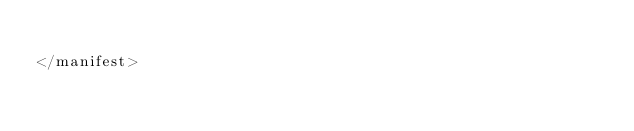<code> <loc_0><loc_0><loc_500><loc_500><_XML_>
</manifest></code> 